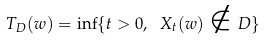<formula> <loc_0><loc_0><loc_500><loc_500>T _ { D } ( w ) = \inf \{ t > 0 , \ X _ { t } ( w ) \notin D \}</formula> 